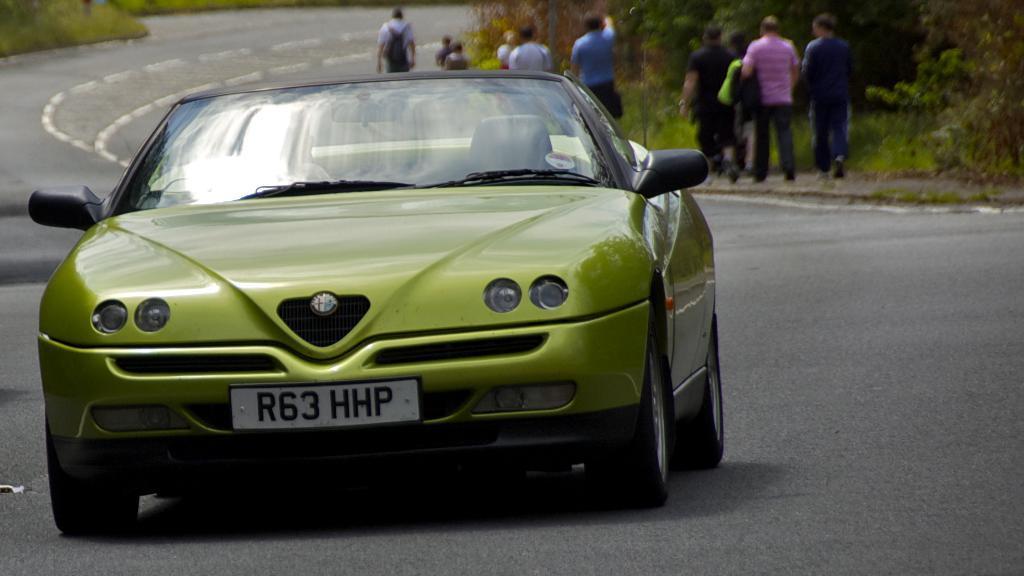Could you give a brief overview of what you see in this image? In this picture I can observe green color car on the road. In the background there are some people walking on the footpath. On either sides of the road there are some plants and trees. 